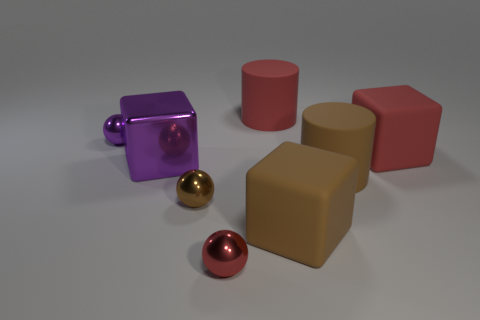Add 1 small green metallic cylinders. How many objects exist? 9 Subtract all rubber blocks. How many blocks are left? 1 Subtract all cubes. How many objects are left? 5 Subtract 1 cubes. How many cubes are left? 2 Subtract all red metallic things. Subtract all large purple matte cylinders. How many objects are left? 7 Add 8 large red rubber objects. How many large red rubber objects are left? 10 Add 5 large red matte cylinders. How many large red matte cylinders exist? 6 Subtract 1 red cylinders. How many objects are left? 7 Subtract all green cubes. Subtract all cyan balls. How many cubes are left? 3 